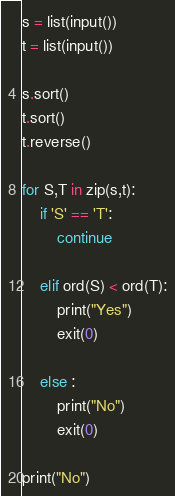<code> <loc_0><loc_0><loc_500><loc_500><_Python_>s = list(input())
t = list(input())

s.sort()
t.sort()
t.reverse()

for S,T in zip(s,t):
	if 'S' == 'T':
		continue

	elif ord(S) < ord(T):
		print("Yes")
		exit(0)

	else :
		print("No") 
		exit(0)

print("No")</code> 